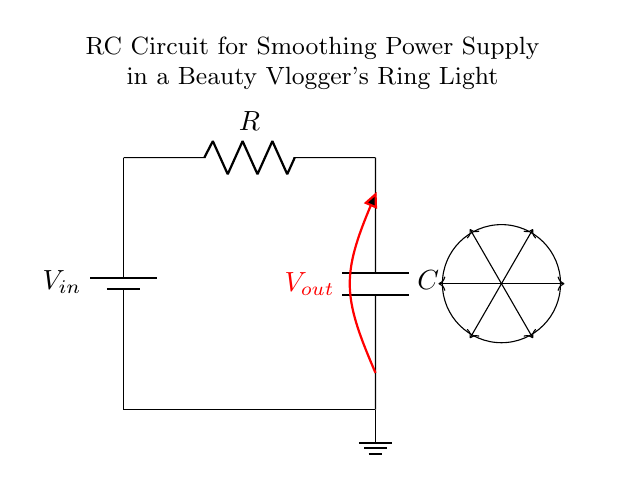What type of circuit is this? The circuit is an RC circuit, characterized by the presence of a resistor and a capacitor in the configuration.
Answer: RC circuit What is the output voltage denoted as? The output voltage is indicated as V out, which represents the voltage across the capacitor and across the load.
Answer: V out What component is represented by the symbol on the left? The leftmost component is a battery, which provides the input voltage to the circuit.
Answer: Battery What is the role of the capacitor in this circuit? The capacitor smooths the output voltage by charging and discharging, effectively filtering out voltage fluctuations.
Answer: Smoothing What happens to the output voltage when the capacitor charges? As the capacitor charges, the output voltage rises and approaches the input voltage, resulting in a more stable voltage supply.
Answer: Rises Why is a resistor included in this circuit? The resistor limits the charging current to the capacitor, ensuring that it charges at an appropriate rate, preventing damage and oscillations.
Answer: Current limiting What effect does increasing the capacitor value have on the circuit? Increasing the capacitor value enhances the smoothing effect by prolonging its charge and discharge times, leading to a more stable output voltage.
Answer: Enhanced smoothing 